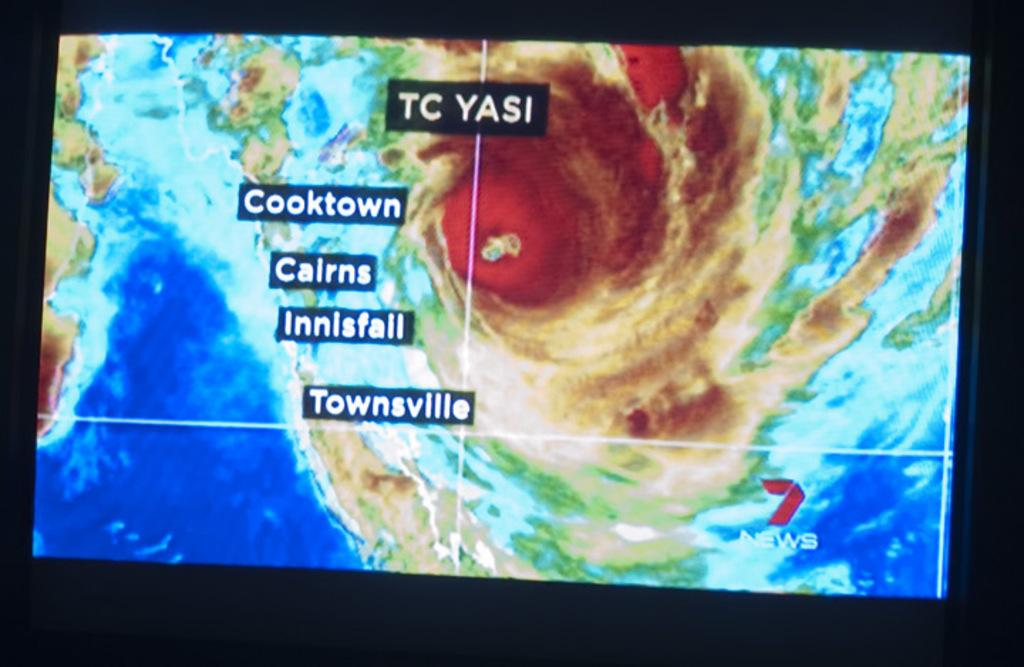<image>
Describe the image concisely. The radar image of a hurricane approching Cooktown. 